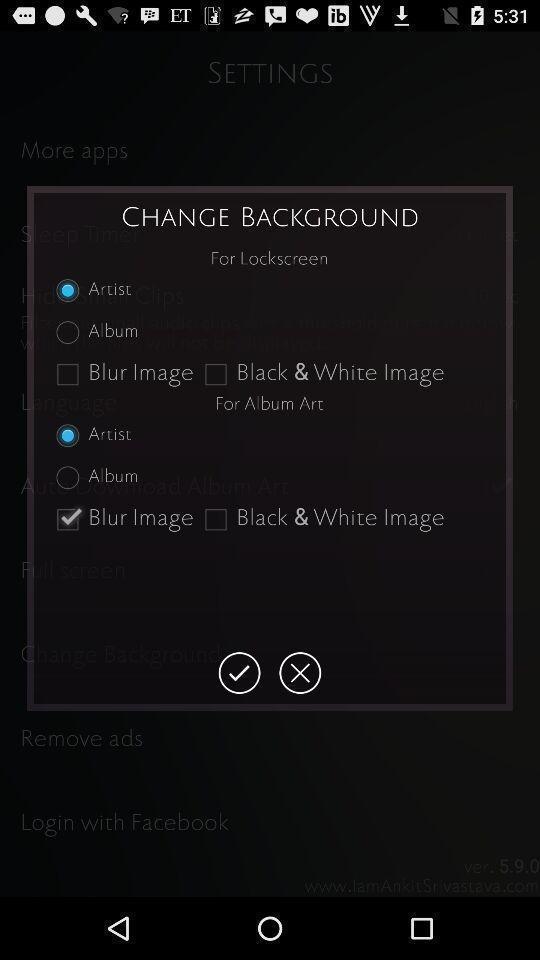Provide a description of this screenshot. Settings tab with options to change the background. 